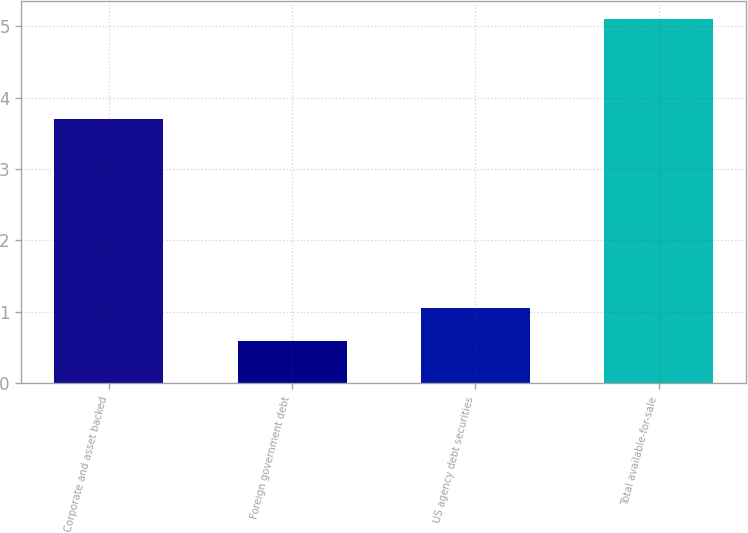<chart> <loc_0><loc_0><loc_500><loc_500><bar_chart><fcel>Corporate and asset backed<fcel>Foreign government debt<fcel>US agency debt securities<fcel>Total available-for-sale<nl><fcel>3.7<fcel>0.6<fcel>1.05<fcel>5.1<nl></chart> 